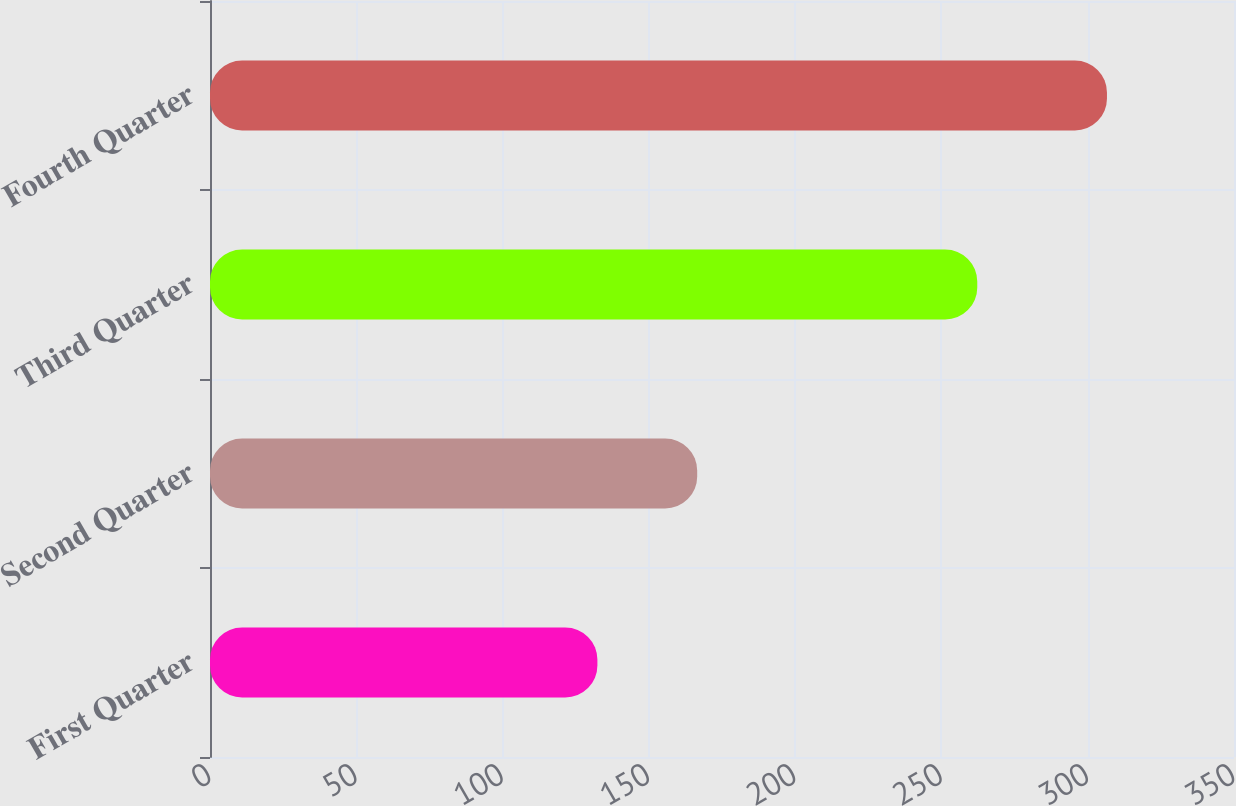Convert chart. <chart><loc_0><loc_0><loc_500><loc_500><bar_chart><fcel>First Quarter<fcel>Second Quarter<fcel>Third Quarter<fcel>Fourth Quarter<nl><fcel>132.41<fcel>166.52<fcel>262.25<fcel>306.58<nl></chart> 